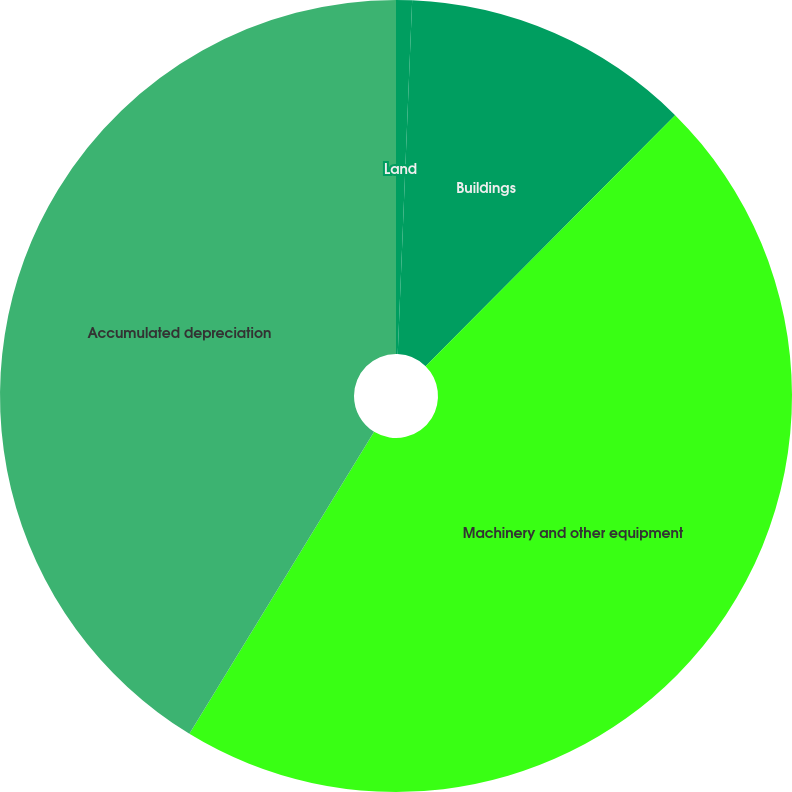Convert chart. <chart><loc_0><loc_0><loc_500><loc_500><pie_chart><fcel>Land<fcel>Buildings<fcel>Machinery and other equipment<fcel>Accumulated depreciation<nl><fcel>0.65%<fcel>11.8%<fcel>46.28%<fcel>41.26%<nl></chart> 